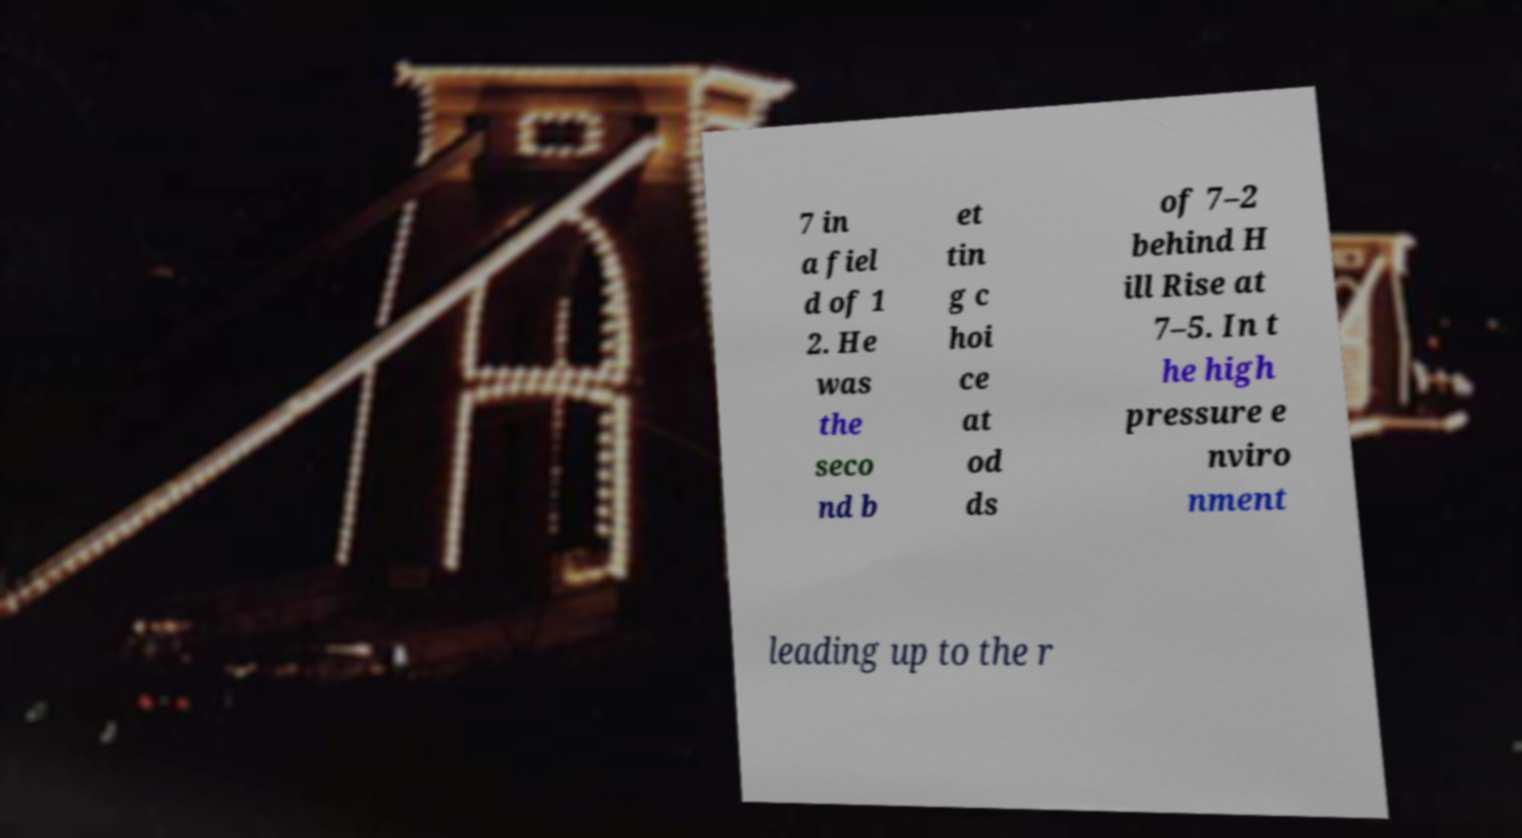For documentation purposes, I need the text within this image transcribed. Could you provide that? 7 in a fiel d of 1 2. He was the seco nd b et tin g c hoi ce at od ds of 7–2 behind H ill Rise at 7–5. In t he high pressure e nviro nment leading up to the r 